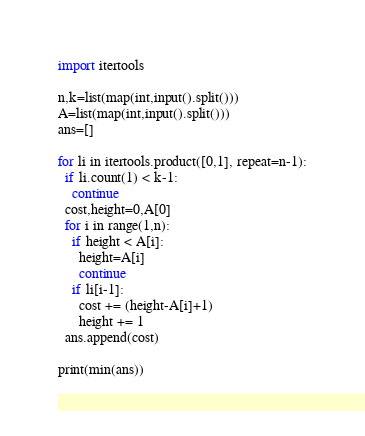<code> <loc_0><loc_0><loc_500><loc_500><_Python_>import itertools

n,k=list(map(int,input().split()))
A=list(map(int,input().split()))
ans=[]

for li in itertools.product([0,1], repeat=n-1):
  if li.count(1) < k-1:
    continue
  cost,height=0,A[0]
  for i in range(1,n):
    if height < A[i]:
      height=A[i]
      continue
    if li[i-1]:
      cost += (height-A[i]+1)
      height += 1 
  ans.append(cost)
  
print(min(ans))</code> 